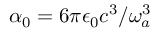Convert formula to latex. <formula><loc_0><loc_0><loc_500><loc_500>\alpha _ { 0 } = 6 \pi \epsilon _ { 0 } c ^ { 3 } / \omega _ { a } ^ { 3 }</formula> 